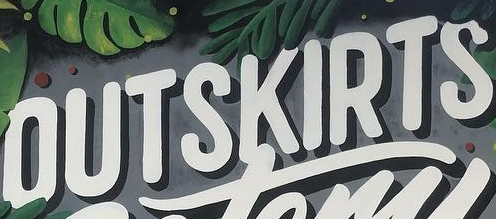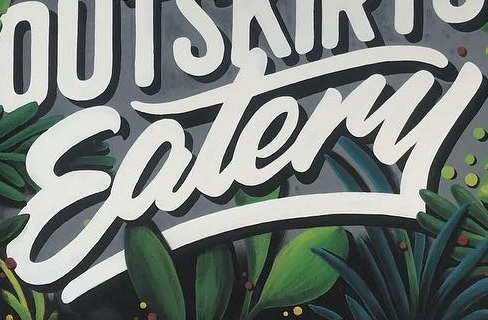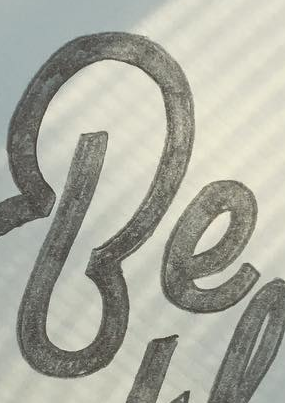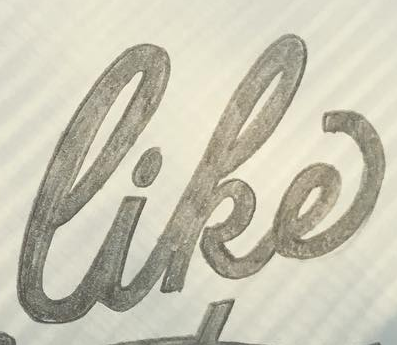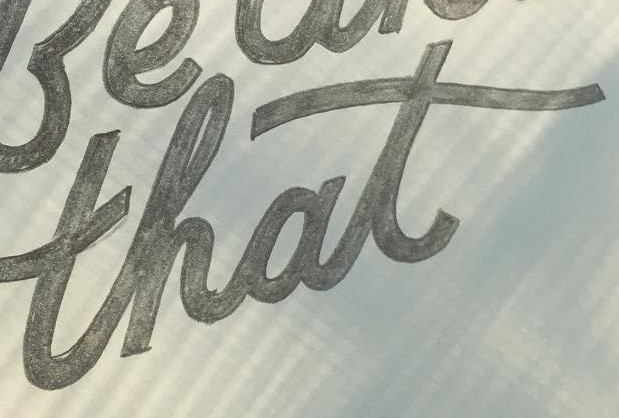Identify the words shown in these images in order, separated by a semicolon. OUTSKIRTS; Eatery; Be; like; that 